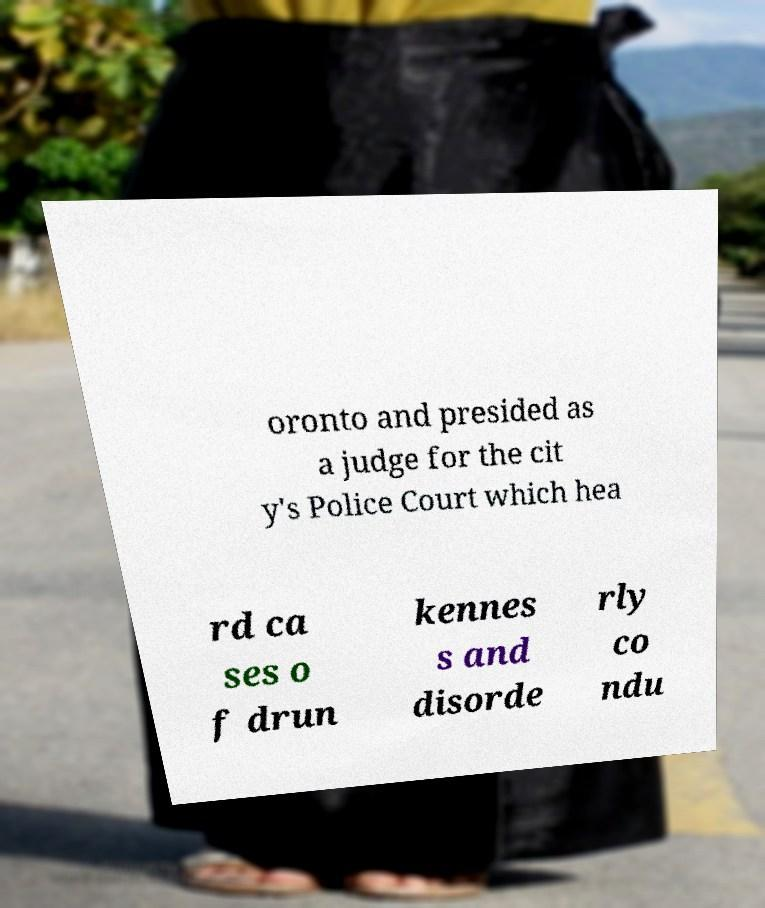Please read and relay the text visible in this image. What does it say? oronto and presided as a judge for the cit y's Police Court which hea rd ca ses o f drun kennes s and disorde rly co ndu 